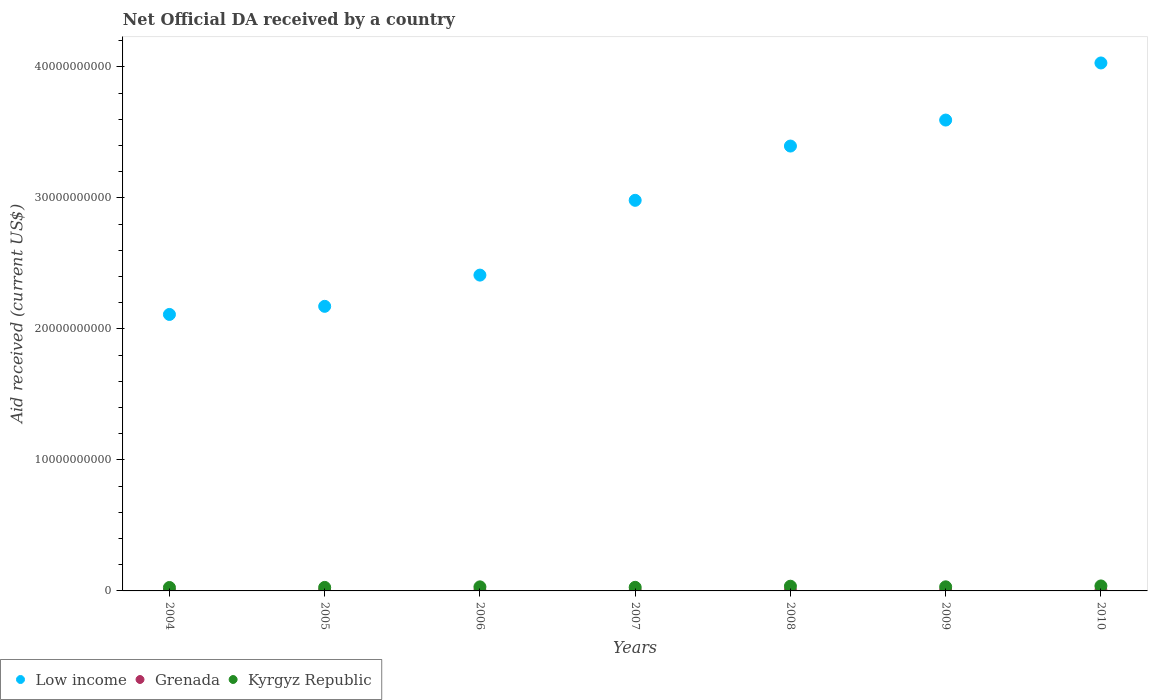How many different coloured dotlines are there?
Your answer should be very brief. 3. Is the number of dotlines equal to the number of legend labels?
Your answer should be very brief. Yes. What is the net official development assistance aid received in Low income in 2010?
Give a very brief answer. 4.03e+1. Across all years, what is the maximum net official development assistance aid received in Grenada?
Give a very brief answer. 5.25e+07. Across all years, what is the minimum net official development assistance aid received in Low income?
Keep it short and to the point. 2.11e+1. In which year was the net official development assistance aid received in Low income maximum?
Ensure brevity in your answer.  2010. In which year was the net official development assistance aid received in Grenada minimum?
Ensure brevity in your answer.  2004. What is the total net official development assistance aid received in Grenada in the graph?
Give a very brief answer. 2.33e+08. What is the difference between the net official development assistance aid received in Kyrgyz Republic in 2005 and that in 2006?
Your answer should be very brief. -4.27e+07. What is the difference between the net official development assistance aid received in Kyrgyz Republic in 2005 and the net official development assistance aid received in Low income in 2009?
Your answer should be compact. -3.57e+1. What is the average net official development assistance aid received in Grenada per year?
Provide a short and direct response. 3.32e+07. In the year 2004, what is the difference between the net official development assistance aid received in Grenada and net official development assistance aid received in Kyrgyz Republic?
Give a very brief answer. -2.46e+08. What is the ratio of the net official development assistance aid received in Grenada in 2007 to that in 2010?
Make the answer very short. 0.68. Is the difference between the net official development assistance aid received in Grenada in 2006 and 2007 greater than the difference between the net official development assistance aid received in Kyrgyz Republic in 2006 and 2007?
Give a very brief answer. No. What is the difference between the highest and the second highest net official development assistance aid received in Low income?
Offer a very short reply. 4.36e+09. What is the difference between the highest and the lowest net official development assistance aid received in Grenada?
Ensure brevity in your answer.  3.69e+07. In how many years, is the net official development assistance aid received in Kyrgyz Republic greater than the average net official development assistance aid received in Kyrgyz Republic taken over all years?
Keep it short and to the point. 4. Is the sum of the net official development assistance aid received in Kyrgyz Republic in 2004 and 2010 greater than the maximum net official development assistance aid received in Low income across all years?
Ensure brevity in your answer.  No. Is the net official development assistance aid received in Kyrgyz Republic strictly greater than the net official development assistance aid received in Low income over the years?
Your answer should be compact. No. Where does the legend appear in the graph?
Provide a succinct answer. Bottom left. How are the legend labels stacked?
Your answer should be compact. Horizontal. What is the title of the graph?
Your answer should be very brief. Net Official DA received by a country. Does "Eritrea" appear as one of the legend labels in the graph?
Ensure brevity in your answer.  No. What is the label or title of the Y-axis?
Make the answer very short. Aid received (current US$). What is the Aid received (current US$) in Low income in 2004?
Give a very brief answer. 2.11e+1. What is the Aid received (current US$) in Grenada in 2004?
Give a very brief answer. 1.56e+07. What is the Aid received (current US$) of Kyrgyz Republic in 2004?
Your answer should be very brief. 2.61e+08. What is the Aid received (current US$) in Low income in 2005?
Your response must be concise. 2.17e+1. What is the Aid received (current US$) in Grenada in 2005?
Ensure brevity in your answer.  5.25e+07. What is the Aid received (current US$) in Kyrgyz Republic in 2005?
Your response must be concise. 2.68e+08. What is the Aid received (current US$) in Low income in 2006?
Ensure brevity in your answer.  2.41e+1. What is the Aid received (current US$) of Grenada in 2006?
Provide a short and direct response. 2.67e+07. What is the Aid received (current US$) in Kyrgyz Republic in 2006?
Offer a terse response. 3.11e+08. What is the Aid received (current US$) of Low income in 2007?
Provide a short and direct response. 2.98e+1. What is the Aid received (current US$) of Grenada in 2007?
Offer a terse response. 2.30e+07. What is the Aid received (current US$) of Kyrgyz Republic in 2007?
Keep it short and to the point. 2.74e+08. What is the Aid received (current US$) in Low income in 2008?
Keep it short and to the point. 3.40e+1. What is the Aid received (current US$) in Grenada in 2008?
Keep it short and to the point. 3.31e+07. What is the Aid received (current US$) of Kyrgyz Republic in 2008?
Your answer should be very brief. 3.60e+08. What is the Aid received (current US$) in Low income in 2009?
Your answer should be very brief. 3.59e+1. What is the Aid received (current US$) in Grenada in 2009?
Your response must be concise. 4.78e+07. What is the Aid received (current US$) in Kyrgyz Republic in 2009?
Keep it short and to the point. 3.13e+08. What is the Aid received (current US$) in Low income in 2010?
Your response must be concise. 4.03e+1. What is the Aid received (current US$) of Grenada in 2010?
Keep it short and to the point. 3.38e+07. What is the Aid received (current US$) of Kyrgyz Republic in 2010?
Keep it short and to the point. 3.80e+08. Across all years, what is the maximum Aid received (current US$) of Low income?
Your answer should be very brief. 4.03e+1. Across all years, what is the maximum Aid received (current US$) of Grenada?
Your answer should be compact. 5.25e+07. Across all years, what is the maximum Aid received (current US$) of Kyrgyz Republic?
Keep it short and to the point. 3.80e+08. Across all years, what is the minimum Aid received (current US$) of Low income?
Your response must be concise. 2.11e+1. Across all years, what is the minimum Aid received (current US$) of Grenada?
Offer a very short reply. 1.56e+07. Across all years, what is the minimum Aid received (current US$) in Kyrgyz Republic?
Give a very brief answer. 2.61e+08. What is the total Aid received (current US$) of Low income in the graph?
Your response must be concise. 2.07e+11. What is the total Aid received (current US$) in Grenada in the graph?
Offer a terse response. 2.33e+08. What is the total Aid received (current US$) in Kyrgyz Republic in the graph?
Provide a succinct answer. 2.17e+09. What is the difference between the Aid received (current US$) of Low income in 2004 and that in 2005?
Provide a succinct answer. -6.19e+08. What is the difference between the Aid received (current US$) of Grenada in 2004 and that in 2005?
Keep it short and to the point. -3.69e+07. What is the difference between the Aid received (current US$) in Kyrgyz Republic in 2004 and that in 2005?
Ensure brevity in your answer.  -6.51e+06. What is the difference between the Aid received (current US$) in Low income in 2004 and that in 2006?
Your answer should be very brief. -3.00e+09. What is the difference between the Aid received (current US$) in Grenada in 2004 and that in 2006?
Offer a terse response. -1.11e+07. What is the difference between the Aid received (current US$) in Kyrgyz Republic in 2004 and that in 2006?
Your response must be concise. -4.92e+07. What is the difference between the Aid received (current US$) in Low income in 2004 and that in 2007?
Offer a terse response. -8.71e+09. What is the difference between the Aid received (current US$) in Grenada in 2004 and that in 2007?
Make the answer very short. -7.41e+06. What is the difference between the Aid received (current US$) in Kyrgyz Republic in 2004 and that in 2007?
Ensure brevity in your answer.  -1.31e+07. What is the difference between the Aid received (current US$) in Low income in 2004 and that in 2008?
Keep it short and to the point. -1.29e+1. What is the difference between the Aid received (current US$) of Grenada in 2004 and that in 2008?
Offer a very short reply. -1.75e+07. What is the difference between the Aid received (current US$) of Kyrgyz Republic in 2004 and that in 2008?
Provide a succinct answer. -9.86e+07. What is the difference between the Aid received (current US$) of Low income in 2004 and that in 2009?
Offer a very short reply. -1.48e+1. What is the difference between the Aid received (current US$) of Grenada in 2004 and that in 2009?
Keep it short and to the point. -3.22e+07. What is the difference between the Aid received (current US$) of Kyrgyz Republic in 2004 and that in 2009?
Give a very brief answer. -5.20e+07. What is the difference between the Aid received (current US$) of Low income in 2004 and that in 2010?
Give a very brief answer. -1.92e+1. What is the difference between the Aid received (current US$) of Grenada in 2004 and that in 2010?
Your response must be concise. -1.82e+07. What is the difference between the Aid received (current US$) in Kyrgyz Republic in 2004 and that in 2010?
Offer a terse response. -1.19e+08. What is the difference between the Aid received (current US$) in Low income in 2005 and that in 2006?
Ensure brevity in your answer.  -2.38e+09. What is the difference between the Aid received (current US$) of Grenada in 2005 and that in 2006?
Provide a short and direct response. 2.58e+07. What is the difference between the Aid received (current US$) in Kyrgyz Republic in 2005 and that in 2006?
Give a very brief answer. -4.27e+07. What is the difference between the Aid received (current US$) of Low income in 2005 and that in 2007?
Offer a terse response. -8.09e+09. What is the difference between the Aid received (current US$) of Grenada in 2005 and that in 2007?
Your answer should be compact. 2.94e+07. What is the difference between the Aid received (current US$) of Kyrgyz Republic in 2005 and that in 2007?
Keep it short and to the point. -6.57e+06. What is the difference between the Aid received (current US$) of Low income in 2005 and that in 2008?
Make the answer very short. -1.22e+1. What is the difference between the Aid received (current US$) in Grenada in 2005 and that in 2008?
Offer a very short reply. 1.94e+07. What is the difference between the Aid received (current US$) of Kyrgyz Republic in 2005 and that in 2008?
Provide a succinct answer. -9.21e+07. What is the difference between the Aid received (current US$) in Low income in 2005 and that in 2009?
Your answer should be compact. -1.42e+1. What is the difference between the Aid received (current US$) in Grenada in 2005 and that in 2009?
Offer a very short reply. 4.69e+06. What is the difference between the Aid received (current US$) of Kyrgyz Republic in 2005 and that in 2009?
Keep it short and to the point. -4.55e+07. What is the difference between the Aid received (current US$) in Low income in 2005 and that in 2010?
Your answer should be very brief. -1.86e+1. What is the difference between the Aid received (current US$) of Grenada in 2005 and that in 2010?
Your answer should be very brief. 1.87e+07. What is the difference between the Aid received (current US$) in Kyrgyz Republic in 2005 and that in 2010?
Your answer should be very brief. -1.12e+08. What is the difference between the Aid received (current US$) in Low income in 2006 and that in 2007?
Make the answer very short. -5.71e+09. What is the difference between the Aid received (current US$) in Grenada in 2006 and that in 2007?
Your answer should be compact. 3.69e+06. What is the difference between the Aid received (current US$) in Kyrgyz Republic in 2006 and that in 2007?
Give a very brief answer. 3.61e+07. What is the difference between the Aid received (current US$) of Low income in 2006 and that in 2008?
Keep it short and to the point. -9.85e+09. What is the difference between the Aid received (current US$) in Grenada in 2006 and that in 2008?
Provide a short and direct response. -6.36e+06. What is the difference between the Aid received (current US$) in Kyrgyz Republic in 2006 and that in 2008?
Give a very brief answer. -4.94e+07. What is the difference between the Aid received (current US$) of Low income in 2006 and that in 2009?
Keep it short and to the point. -1.18e+1. What is the difference between the Aid received (current US$) in Grenada in 2006 and that in 2009?
Offer a terse response. -2.11e+07. What is the difference between the Aid received (current US$) in Kyrgyz Republic in 2006 and that in 2009?
Provide a succinct answer. -2.83e+06. What is the difference between the Aid received (current US$) in Low income in 2006 and that in 2010?
Your answer should be very brief. -1.62e+1. What is the difference between the Aid received (current US$) in Grenada in 2006 and that in 2010?
Offer a very short reply. -7.10e+06. What is the difference between the Aid received (current US$) of Kyrgyz Republic in 2006 and that in 2010?
Ensure brevity in your answer.  -6.98e+07. What is the difference between the Aid received (current US$) in Low income in 2007 and that in 2008?
Your answer should be compact. -4.14e+09. What is the difference between the Aid received (current US$) of Grenada in 2007 and that in 2008?
Your answer should be compact. -1.00e+07. What is the difference between the Aid received (current US$) of Kyrgyz Republic in 2007 and that in 2008?
Your answer should be very brief. -8.55e+07. What is the difference between the Aid received (current US$) of Low income in 2007 and that in 2009?
Keep it short and to the point. -6.13e+09. What is the difference between the Aid received (current US$) in Grenada in 2007 and that in 2009?
Your answer should be compact. -2.48e+07. What is the difference between the Aid received (current US$) in Kyrgyz Republic in 2007 and that in 2009?
Ensure brevity in your answer.  -3.89e+07. What is the difference between the Aid received (current US$) of Low income in 2007 and that in 2010?
Your answer should be compact. -1.05e+1. What is the difference between the Aid received (current US$) of Grenada in 2007 and that in 2010?
Ensure brevity in your answer.  -1.08e+07. What is the difference between the Aid received (current US$) in Kyrgyz Republic in 2007 and that in 2010?
Your answer should be very brief. -1.06e+08. What is the difference between the Aid received (current US$) in Low income in 2008 and that in 2009?
Give a very brief answer. -1.98e+09. What is the difference between the Aid received (current US$) of Grenada in 2008 and that in 2009?
Keep it short and to the point. -1.47e+07. What is the difference between the Aid received (current US$) of Kyrgyz Republic in 2008 and that in 2009?
Your answer should be very brief. 4.66e+07. What is the difference between the Aid received (current US$) in Low income in 2008 and that in 2010?
Give a very brief answer. -6.34e+09. What is the difference between the Aid received (current US$) in Grenada in 2008 and that in 2010?
Ensure brevity in your answer.  -7.40e+05. What is the difference between the Aid received (current US$) in Kyrgyz Republic in 2008 and that in 2010?
Your answer should be very brief. -2.04e+07. What is the difference between the Aid received (current US$) of Low income in 2009 and that in 2010?
Give a very brief answer. -4.36e+09. What is the difference between the Aid received (current US$) in Grenada in 2009 and that in 2010?
Your response must be concise. 1.40e+07. What is the difference between the Aid received (current US$) in Kyrgyz Republic in 2009 and that in 2010?
Ensure brevity in your answer.  -6.70e+07. What is the difference between the Aid received (current US$) of Low income in 2004 and the Aid received (current US$) of Grenada in 2005?
Your answer should be compact. 2.11e+1. What is the difference between the Aid received (current US$) in Low income in 2004 and the Aid received (current US$) in Kyrgyz Republic in 2005?
Ensure brevity in your answer.  2.08e+1. What is the difference between the Aid received (current US$) of Grenada in 2004 and the Aid received (current US$) of Kyrgyz Republic in 2005?
Make the answer very short. -2.52e+08. What is the difference between the Aid received (current US$) in Low income in 2004 and the Aid received (current US$) in Grenada in 2006?
Your answer should be very brief. 2.11e+1. What is the difference between the Aid received (current US$) of Low income in 2004 and the Aid received (current US$) of Kyrgyz Republic in 2006?
Give a very brief answer. 2.08e+1. What is the difference between the Aid received (current US$) of Grenada in 2004 and the Aid received (current US$) of Kyrgyz Republic in 2006?
Your answer should be compact. -2.95e+08. What is the difference between the Aid received (current US$) of Low income in 2004 and the Aid received (current US$) of Grenada in 2007?
Keep it short and to the point. 2.11e+1. What is the difference between the Aid received (current US$) in Low income in 2004 and the Aid received (current US$) in Kyrgyz Republic in 2007?
Your answer should be very brief. 2.08e+1. What is the difference between the Aid received (current US$) in Grenada in 2004 and the Aid received (current US$) in Kyrgyz Republic in 2007?
Provide a succinct answer. -2.59e+08. What is the difference between the Aid received (current US$) in Low income in 2004 and the Aid received (current US$) in Grenada in 2008?
Give a very brief answer. 2.11e+1. What is the difference between the Aid received (current US$) in Low income in 2004 and the Aid received (current US$) in Kyrgyz Republic in 2008?
Your response must be concise. 2.07e+1. What is the difference between the Aid received (current US$) of Grenada in 2004 and the Aid received (current US$) of Kyrgyz Republic in 2008?
Offer a terse response. -3.44e+08. What is the difference between the Aid received (current US$) of Low income in 2004 and the Aid received (current US$) of Grenada in 2009?
Offer a terse response. 2.11e+1. What is the difference between the Aid received (current US$) in Low income in 2004 and the Aid received (current US$) in Kyrgyz Republic in 2009?
Provide a short and direct response. 2.08e+1. What is the difference between the Aid received (current US$) of Grenada in 2004 and the Aid received (current US$) of Kyrgyz Republic in 2009?
Offer a terse response. -2.98e+08. What is the difference between the Aid received (current US$) in Low income in 2004 and the Aid received (current US$) in Grenada in 2010?
Ensure brevity in your answer.  2.11e+1. What is the difference between the Aid received (current US$) of Low income in 2004 and the Aid received (current US$) of Kyrgyz Republic in 2010?
Give a very brief answer. 2.07e+1. What is the difference between the Aid received (current US$) in Grenada in 2004 and the Aid received (current US$) in Kyrgyz Republic in 2010?
Make the answer very short. -3.65e+08. What is the difference between the Aid received (current US$) in Low income in 2005 and the Aid received (current US$) in Grenada in 2006?
Provide a short and direct response. 2.17e+1. What is the difference between the Aid received (current US$) of Low income in 2005 and the Aid received (current US$) of Kyrgyz Republic in 2006?
Provide a succinct answer. 2.14e+1. What is the difference between the Aid received (current US$) of Grenada in 2005 and the Aid received (current US$) of Kyrgyz Republic in 2006?
Offer a very short reply. -2.58e+08. What is the difference between the Aid received (current US$) in Low income in 2005 and the Aid received (current US$) in Grenada in 2007?
Provide a short and direct response. 2.17e+1. What is the difference between the Aid received (current US$) of Low income in 2005 and the Aid received (current US$) of Kyrgyz Republic in 2007?
Your answer should be very brief. 2.14e+1. What is the difference between the Aid received (current US$) of Grenada in 2005 and the Aid received (current US$) of Kyrgyz Republic in 2007?
Ensure brevity in your answer.  -2.22e+08. What is the difference between the Aid received (current US$) of Low income in 2005 and the Aid received (current US$) of Grenada in 2008?
Your response must be concise. 2.17e+1. What is the difference between the Aid received (current US$) in Low income in 2005 and the Aid received (current US$) in Kyrgyz Republic in 2008?
Your response must be concise. 2.14e+1. What is the difference between the Aid received (current US$) of Grenada in 2005 and the Aid received (current US$) of Kyrgyz Republic in 2008?
Make the answer very short. -3.07e+08. What is the difference between the Aid received (current US$) in Low income in 2005 and the Aid received (current US$) in Grenada in 2009?
Give a very brief answer. 2.17e+1. What is the difference between the Aid received (current US$) of Low income in 2005 and the Aid received (current US$) of Kyrgyz Republic in 2009?
Provide a short and direct response. 2.14e+1. What is the difference between the Aid received (current US$) of Grenada in 2005 and the Aid received (current US$) of Kyrgyz Republic in 2009?
Your answer should be compact. -2.61e+08. What is the difference between the Aid received (current US$) in Low income in 2005 and the Aid received (current US$) in Grenada in 2010?
Your response must be concise. 2.17e+1. What is the difference between the Aid received (current US$) of Low income in 2005 and the Aid received (current US$) of Kyrgyz Republic in 2010?
Give a very brief answer. 2.13e+1. What is the difference between the Aid received (current US$) of Grenada in 2005 and the Aid received (current US$) of Kyrgyz Republic in 2010?
Provide a short and direct response. -3.28e+08. What is the difference between the Aid received (current US$) in Low income in 2006 and the Aid received (current US$) in Grenada in 2007?
Provide a succinct answer. 2.41e+1. What is the difference between the Aid received (current US$) in Low income in 2006 and the Aid received (current US$) in Kyrgyz Republic in 2007?
Give a very brief answer. 2.38e+1. What is the difference between the Aid received (current US$) in Grenada in 2006 and the Aid received (current US$) in Kyrgyz Republic in 2007?
Offer a very short reply. -2.48e+08. What is the difference between the Aid received (current US$) in Low income in 2006 and the Aid received (current US$) in Grenada in 2008?
Give a very brief answer. 2.41e+1. What is the difference between the Aid received (current US$) in Low income in 2006 and the Aid received (current US$) in Kyrgyz Republic in 2008?
Provide a short and direct response. 2.37e+1. What is the difference between the Aid received (current US$) in Grenada in 2006 and the Aid received (current US$) in Kyrgyz Republic in 2008?
Your answer should be very brief. -3.33e+08. What is the difference between the Aid received (current US$) of Low income in 2006 and the Aid received (current US$) of Grenada in 2009?
Offer a terse response. 2.41e+1. What is the difference between the Aid received (current US$) in Low income in 2006 and the Aid received (current US$) in Kyrgyz Republic in 2009?
Make the answer very short. 2.38e+1. What is the difference between the Aid received (current US$) of Grenada in 2006 and the Aid received (current US$) of Kyrgyz Republic in 2009?
Make the answer very short. -2.87e+08. What is the difference between the Aid received (current US$) in Low income in 2006 and the Aid received (current US$) in Grenada in 2010?
Your answer should be very brief. 2.41e+1. What is the difference between the Aid received (current US$) in Low income in 2006 and the Aid received (current US$) in Kyrgyz Republic in 2010?
Make the answer very short. 2.37e+1. What is the difference between the Aid received (current US$) of Grenada in 2006 and the Aid received (current US$) of Kyrgyz Republic in 2010?
Ensure brevity in your answer.  -3.54e+08. What is the difference between the Aid received (current US$) of Low income in 2007 and the Aid received (current US$) of Grenada in 2008?
Your response must be concise. 2.98e+1. What is the difference between the Aid received (current US$) of Low income in 2007 and the Aid received (current US$) of Kyrgyz Republic in 2008?
Give a very brief answer. 2.95e+1. What is the difference between the Aid received (current US$) in Grenada in 2007 and the Aid received (current US$) in Kyrgyz Republic in 2008?
Give a very brief answer. -3.37e+08. What is the difference between the Aid received (current US$) in Low income in 2007 and the Aid received (current US$) in Grenada in 2009?
Offer a very short reply. 2.98e+1. What is the difference between the Aid received (current US$) of Low income in 2007 and the Aid received (current US$) of Kyrgyz Republic in 2009?
Give a very brief answer. 2.95e+1. What is the difference between the Aid received (current US$) in Grenada in 2007 and the Aid received (current US$) in Kyrgyz Republic in 2009?
Provide a succinct answer. -2.90e+08. What is the difference between the Aid received (current US$) of Low income in 2007 and the Aid received (current US$) of Grenada in 2010?
Your answer should be compact. 2.98e+1. What is the difference between the Aid received (current US$) in Low income in 2007 and the Aid received (current US$) in Kyrgyz Republic in 2010?
Provide a short and direct response. 2.94e+1. What is the difference between the Aid received (current US$) of Grenada in 2007 and the Aid received (current US$) of Kyrgyz Republic in 2010?
Provide a succinct answer. -3.57e+08. What is the difference between the Aid received (current US$) of Low income in 2008 and the Aid received (current US$) of Grenada in 2009?
Your response must be concise. 3.39e+1. What is the difference between the Aid received (current US$) of Low income in 2008 and the Aid received (current US$) of Kyrgyz Republic in 2009?
Your answer should be very brief. 3.36e+1. What is the difference between the Aid received (current US$) in Grenada in 2008 and the Aid received (current US$) in Kyrgyz Republic in 2009?
Provide a short and direct response. -2.80e+08. What is the difference between the Aid received (current US$) in Low income in 2008 and the Aid received (current US$) in Grenada in 2010?
Keep it short and to the point. 3.39e+1. What is the difference between the Aid received (current US$) of Low income in 2008 and the Aid received (current US$) of Kyrgyz Republic in 2010?
Give a very brief answer. 3.36e+1. What is the difference between the Aid received (current US$) of Grenada in 2008 and the Aid received (current US$) of Kyrgyz Republic in 2010?
Provide a succinct answer. -3.47e+08. What is the difference between the Aid received (current US$) in Low income in 2009 and the Aid received (current US$) in Grenada in 2010?
Your answer should be compact. 3.59e+1. What is the difference between the Aid received (current US$) of Low income in 2009 and the Aid received (current US$) of Kyrgyz Republic in 2010?
Your response must be concise. 3.56e+1. What is the difference between the Aid received (current US$) in Grenada in 2009 and the Aid received (current US$) in Kyrgyz Republic in 2010?
Make the answer very short. -3.33e+08. What is the average Aid received (current US$) in Low income per year?
Your response must be concise. 2.96e+1. What is the average Aid received (current US$) in Grenada per year?
Keep it short and to the point. 3.32e+07. What is the average Aid received (current US$) of Kyrgyz Republic per year?
Your answer should be compact. 3.10e+08. In the year 2004, what is the difference between the Aid received (current US$) of Low income and Aid received (current US$) of Grenada?
Offer a terse response. 2.11e+1. In the year 2004, what is the difference between the Aid received (current US$) in Low income and Aid received (current US$) in Kyrgyz Republic?
Your response must be concise. 2.08e+1. In the year 2004, what is the difference between the Aid received (current US$) of Grenada and Aid received (current US$) of Kyrgyz Republic?
Provide a short and direct response. -2.46e+08. In the year 2005, what is the difference between the Aid received (current US$) of Low income and Aid received (current US$) of Grenada?
Your response must be concise. 2.17e+1. In the year 2005, what is the difference between the Aid received (current US$) in Low income and Aid received (current US$) in Kyrgyz Republic?
Keep it short and to the point. 2.15e+1. In the year 2005, what is the difference between the Aid received (current US$) of Grenada and Aid received (current US$) of Kyrgyz Republic?
Keep it short and to the point. -2.15e+08. In the year 2006, what is the difference between the Aid received (current US$) in Low income and Aid received (current US$) in Grenada?
Make the answer very short. 2.41e+1. In the year 2006, what is the difference between the Aid received (current US$) in Low income and Aid received (current US$) in Kyrgyz Republic?
Offer a terse response. 2.38e+1. In the year 2006, what is the difference between the Aid received (current US$) of Grenada and Aid received (current US$) of Kyrgyz Republic?
Give a very brief answer. -2.84e+08. In the year 2007, what is the difference between the Aid received (current US$) of Low income and Aid received (current US$) of Grenada?
Ensure brevity in your answer.  2.98e+1. In the year 2007, what is the difference between the Aid received (current US$) in Low income and Aid received (current US$) in Kyrgyz Republic?
Ensure brevity in your answer.  2.95e+1. In the year 2007, what is the difference between the Aid received (current US$) in Grenada and Aid received (current US$) in Kyrgyz Republic?
Your answer should be very brief. -2.51e+08. In the year 2008, what is the difference between the Aid received (current US$) of Low income and Aid received (current US$) of Grenada?
Provide a succinct answer. 3.39e+1. In the year 2008, what is the difference between the Aid received (current US$) in Low income and Aid received (current US$) in Kyrgyz Republic?
Your response must be concise. 3.36e+1. In the year 2008, what is the difference between the Aid received (current US$) in Grenada and Aid received (current US$) in Kyrgyz Republic?
Provide a short and direct response. -3.27e+08. In the year 2009, what is the difference between the Aid received (current US$) of Low income and Aid received (current US$) of Grenada?
Give a very brief answer. 3.59e+1. In the year 2009, what is the difference between the Aid received (current US$) in Low income and Aid received (current US$) in Kyrgyz Republic?
Give a very brief answer. 3.56e+1. In the year 2009, what is the difference between the Aid received (current US$) of Grenada and Aid received (current US$) of Kyrgyz Republic?
Make the answer very short. -2.66e+08. In the year 2010, what is the difference between the Aid received (current US$) of Low income and Aid received (current US$) of Grenada?
Your answer should be compact. 4.03e+1. In the year 2010, what is the difference between the Aid received (current US$) in Low income and Aid received (current US$) in Kyrgyz Republic?
Provide a short and direct response. 3.99e+1. In the year 2010, what is the difference between the Aid received (current US$) of Grenada and Aid received (current US$) of Kyrgyz Republic?
Offer a terse response. -3.47e+08. What is the ratio of the Aid received (current US$) of Low income in 2004 to that in 2005?
Offer a terse response. 0.97. What is the ratio of the Aid received (current US$) in Grenada in 2004 to that in 2005?
Provide a succinct answer. 0.3. What is the ratio of the Aid received (current US$) in Kyrgyz Republic in 2004 to that in 2005?
Provide a short and direct response. 0.98. What is the ratio of the Aid received (current US$) in Low income in 2004 to that in 2006?
Your answer should be compact. 0.88. What is the ratio of the Aid received (current US$) in Grenada in 2004 to that in 2006?
Give a very brief answer. 0.58. What is the ratio of the Aid received (current US$) of Kyrgyz Republic in 2004 to that in 2006?
Ensure brevity in your answer.  0.84. What is the ratio of the Aid received (current US$) in Low income in 2004 to that in 2007?
Provide a succinct answer. 0.71. What is the ratio of the Aid received (current US$) of Grenada in 2004 to that in 2007?
Provide a succinct answer. 0.68. What is the ratio of the Aid received (current US$) of Kyrgyz Republic in 2004 to that in 2007?
Your answer should be very brief. 0.95. What is the ratio of the Aid received (current US$) in Low income in 2004 to that in 2008?
Keep it short and to the point. 0.62. What is the ratio of the Aid received (current US$) in Grenada in 2004 to that in 2008?
Offer a terse response. 0.47. What is the ratio of the Aid received (current US$) of Kyrgyz Republic in 2004 to that in 2008?
Provide a succinct answer. 0.73. What is the ratio of the Aid received (current US$) of Low income in 2004 to that in 2009?
Your response must be concise. 0.59. What is the ratio of the Aid received (current US$) of Grenada in 2004 to that in 2009?
Keep it short and to the point. 0.33. What is the ratio of the Aid received (current US$) of Kyrgyz Republic in 2004 to that in 2009?
Your answer should be very brief. 0.83. What is the ratio of the Aid received (current US$) in Low income in 2004 to that in 2010?
Offer a terse response. 0.52. What is the ratio of the Aid received (current US$) in Grenada in 2004 to that in 2010?
Offer a terse response. 0.46. What is the ratio of the Aid received (current US$) of Kyrgyz Republic in 2004 to that in 2010?
Keep it short and to the point. 0.69. What is the ratio of the Aid received (current US$) in Low income in 2005 to that in 2006?
Keep it short and to the point. 0.9. What is the ratio of the Aid received (current US$) of Grenada in 2005 to that in 2006?
Provide a succinct answer. 1.96. What is the ratio of the Aid received (current US$) in Kyrgyz Republic in 2005 to that in 2006?
Offer a terse response. 0.86. What is the ratio of the Aid received (current US$) of Low income in 2005 to that in 2007?
Give a very brief answer. 0.73. What is the ratio of the Aid received (current US$) of Grenada in 2005 to that in 2007?
Provide a short and direct response. 2.28. What is the ratio of the Aid received (current US$) in Kyrgyz Republic in 2005 to that in 2007?
Ensure brevity in your answer.  0.98. What is the ratio of the Aid received (current US$) in Low income in 2005 to that in 2008?
Ensure brevity in your answer.  0.64. What is the ratio of the Aid received (current US$) in Grenada in 2005 to that in 2008?
Ensure brevity in your answer.  1.59. What is the ratio of the Aid received (current US$) in Kyrgyz Republic in 2005 to that in 2008?
Make the answer very short. 0.74. What is the ratio of the Aid received (current US$) of Low income in 2005 to that in 2009?
Offer a terse response. 0.6. What is the ratio of the Aid received (current US$) of Grenada in 2005 to that in 2009?
Keep it short and to the point. 1.1. What is the ratio of the Aid received (current US$) in Kyrgyz Republic in 2005 to that in 2009?
Offer a terse response. 0.85. What is the ratio of the Aid received (current US$) in Low income in 2005 to that in 2010?
Offer a very short reply. 0.54. What is the ratio of the Aid received (current US$) of Grenada in 2005 to that in 2010?
Ensure brevity in your answer.  1.55. What is the ratio of the Aid received (current US$) of Kyrgyz Republic in 2005 to that in 2010?
Offer a terse response. 0.7. What is the ratio of the Aid received (current US$) of Low income in 2006 to that in 2007?
Your answer should be very brief. 0.81. What is the ratio of the Aid received (current US$) of Grenada in 2006 to that in 2007?
Offer a very short reply. 1.16. What is the ratio of the Aid received (current US$) of Kyrgyz Republic in 2006 to that in 2007?
Provide a short and direct response. 1.13. What is the ratio of the Aid received (current US$) in Low income in 2006 to that in 2008?
Ensure brevity in your answer.  0.71. What is the ratio of the Aid received (current US$) of Grenada in 2006 to that in 2008?
Your response must be concise. 0.81. What is the ratio of the Aid received (current US$) in Kyrgyz Republic in 2006 to that in 2008?
Ensure brevity in your answer.  0.86. What is the ratio of the Aid received (current US$) in Low income in 2006 to that in 2009?
Provide a succinct answer. 0.67. What is the ratio of the Aid received (current US$) of Grenada in 2006 to that in 2009?
Keep it short and to the point. 0.56. What is the ratio of the Aid received (current US$) in Kyrgyz Republic in 2006 to that in 2009?
Offer a terse response. 0.99. What is the ratio of the Aid received (current US$) of Low income in 2006 to that in 2010?
Ensure brevity in your answer.  0.6. What is the ratio of the Aid received (current US$) in Grenada in 2006 to that in 2010?
Your response must be concise. 0.79. What is the ratio of the Aid received (current US$) of Kyrgyz Republic in 2006 to that in 2010?
Your answer should be compact. 0.82. What is the ratio of the Aid received (current US$) in Low income in 2007 to that in 2008?
Provide a short and direct response. 0.88. What is the ratio of the Aid received (current US$) in Grenada in 2007 to that in 2008?
Offer a terse response. 0.7. What is the ratio of the Aid received (current US$) of Kyrgyz Republic in 2007 to that in 2008?
Provide a succinct answer. 0.76. What is the ratio of the Aid received (current US$) of Low income in 2007 to that in 2009?
Your answer should be compact. 0.83. What is the ratio of the Aid received (current US$) in Grenada in 2007 to that in 2009?
Your answer should be compact. 0.48. What is the ratio of the Aid received (current US$) in Kyrgyz Republic in 2007 to that in 2009?
Keep it short and to the point. 0.88. What is the ratio of the Aid received (current US$) of Low income in 2007 to that in 2010?
Offer a very short reply. 0.74. What is the ratio of the Aid received (current US$) of Grenada in 2007 to that in 2010?
Your answer should be very brief. 0.68. What is the ratio of the Aid received (current US$) in Kyrgyz Republic in 2007 to that in 2010?
Offer a very short reply. 0.72. What is the ratio of the Aid received (current US$) of Low income in 2008 to that in 2009?
Provide a short and direct response. 0.94. What is the ratio of the Aid received (current US$) in Grenada in 2008 to that in 2009?
Ensure brevity in your answer.  0.69. What is the ratio of the Aid received (current US$) of Kyrgyz Republic in 2008 to that in 2009?
Offer a very short reply. 1.15. What is the ratio of the Aid received (current US$) in Low income in 2008 to that in 2010?
Your response must be concise. 0.84. What is the ratio of the Aid received (current US$) of Grenada in 2008 to that in 2010?
Ensure brevity in your answer.  0.98. What is the ratio of the Aid received (current US$) of Kyrgyz Republic in 2008 to that in 2010?
Your response must be concise. 0.95. What is the ratio of the Aid received (current US$) of Low income in 2009 to that in 2010?
Give a very brief answer. 0.89. What is the ratio of the Aid received (current US$) in Grenada in 2009 to that in 2010?
Offer a very short reply. 1.41. What is the ratio of the Aid received (current US$) in Kyrgyz Republic in 2009 to that in 2010?
Keep it short and to the point. 0.82. What is the difference between the highest and the second highest Aid received (current US$) of Low income?
Your answer should be very brief. 4.36e+09. What is the difference between the highest and the second highest Aid received (current US$) of Grenada?
Your answer should be very brief. 4.69e+06. What is the difference between the highest and the second highest Aid received (current US$) in Kyrgyz Republic?
Give a very brief answer. 2.04e+07. What is the difference between the highest and the lowest Aid received (current US$) in Low income?
Your response must be concise. 1.92e+1. What is the difference between the highest and the lowest Aid received (current US$) in Grenada?
Ensure brevity in your answer.  3.69e+07. What is the difference between the highest and the lowest Aid received (current US$) in Kyrgyz Republic?
Provide a succinct answer. 1.19e+08. 